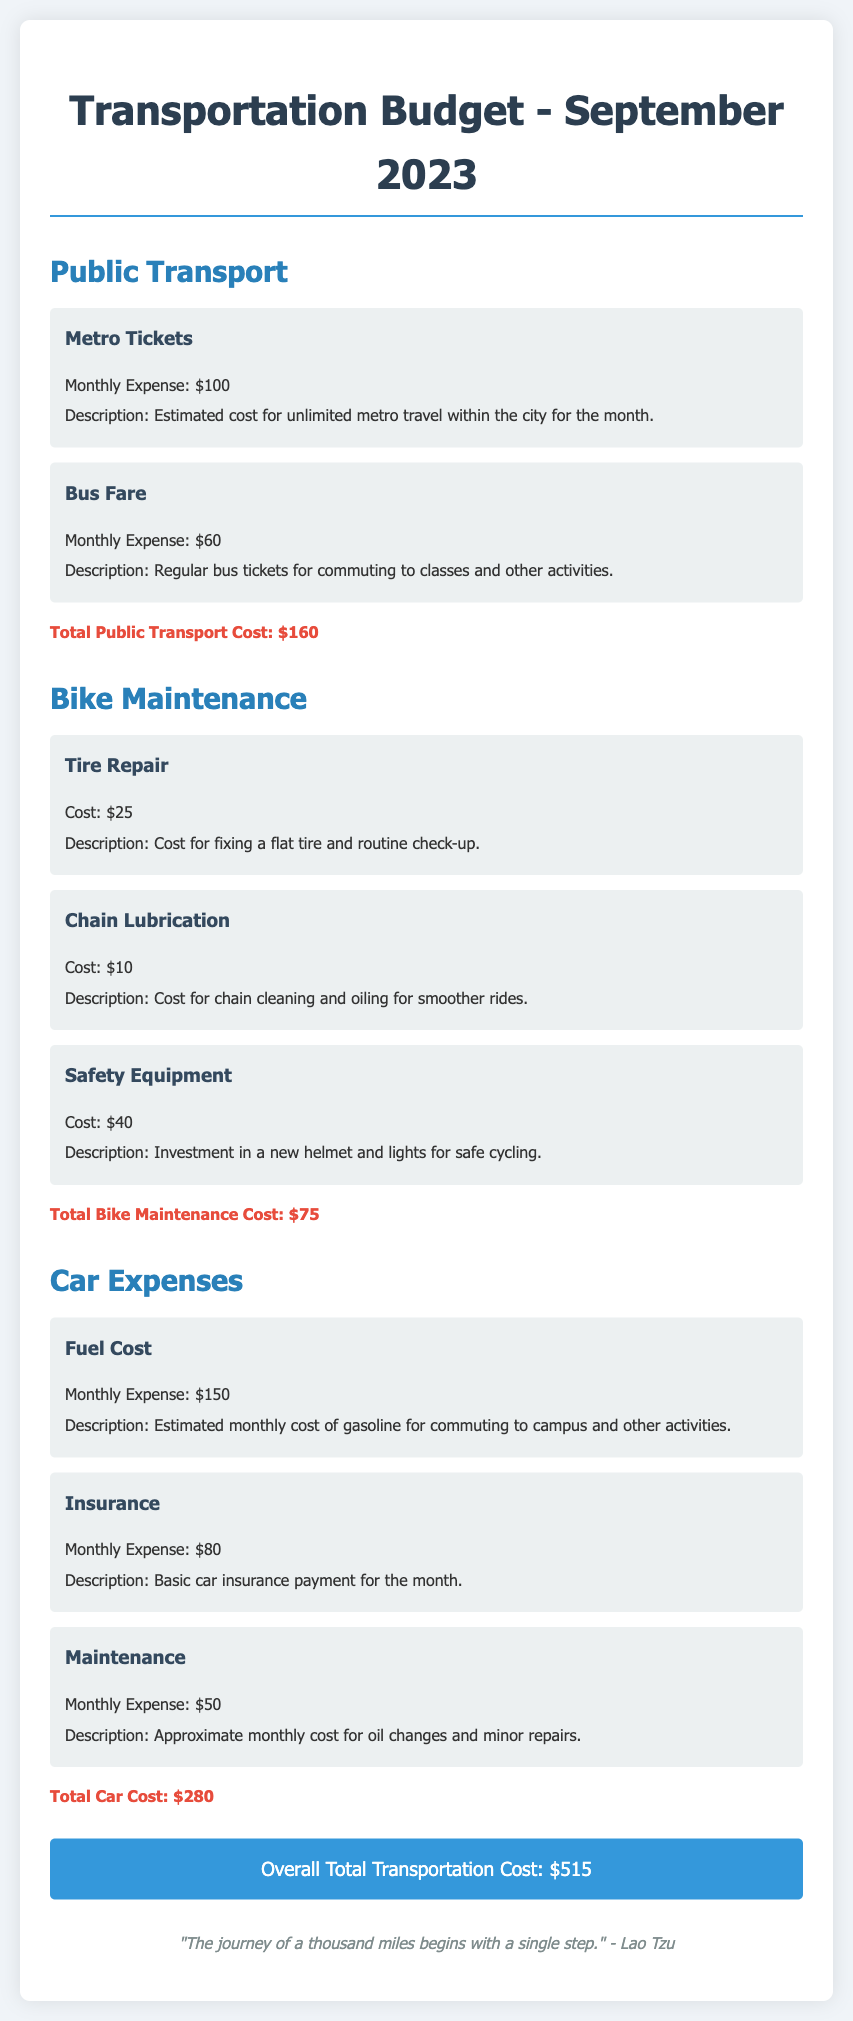What is the total cost for public transport? The total cost for public transport is calculated by adding the costs of metro tickets and bus fare, which is $100 + $60 = $160.
Answer: $160 What is the expense for bike maintenance? The expense for bike maintenance is the sum of tire repair, chain lubrication, and safety equipment, totaling $25 + $10 + $40 = $75.
Answer: $75 What is the monthly fuel cost for the car? The monthly fuel cost for the car is listed as $150 in the document.
Answer: $150 What is the total transportation cost for September 2023? The total transportation cost is the overall sum of all transportation expenses mentioned, which equals $160 + $75 + $280 = $515.
Answer: $515 How much was spent on car insurance? The amount spent on car insurance is clearly stated as $80 in the document.
Answer: $80 What is the cost of tire repair for the bike? The cost of tire repair for the bike is specified as $25 in the document.
Answer: $25 What is the total cost for car maintenance? The total cost for car maintenance includes fuel, insurance, and regular maintenance, amounting to $150 + $80 + $50 = $280.
Answer: $280 How much did the student invest in safety equipment for the bike? The investment in safety equipment is shown to be $40 in the document.
Answer: $40 What quote is included at the end of the document? The quote included at the end of the document is from Lao Tzu and is an inspirational quote regarding journeys.
Answer: "The journey of a thousand miles begins with a single step." - Lao Tzu 